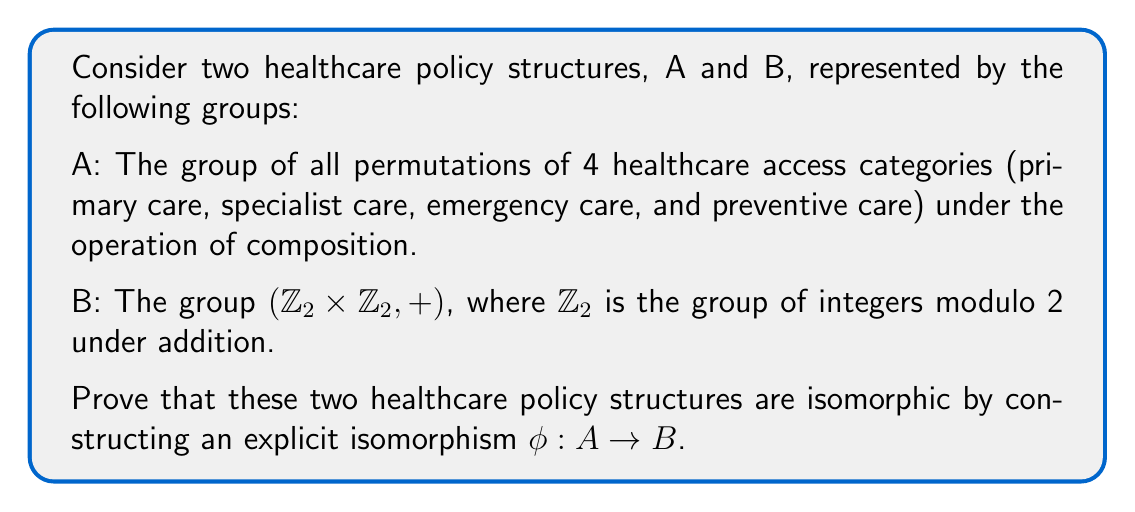Could you help me with this problem? To prove that the two healthcare policy structures A and B are isomorphic, we need to construct a bijective homomorphism $\phi: A \rightarrow B$. Let's approach this step-by-step:

1) First, let's analyze group A:
   - A is the symmetric group $S_4$, which has 24 elements.
   - However, we're only interested in the subgroup that consists of permutations that swap pairs of elements, which has 4 elements.

2) Now, let's look at group B:
   - B is $\mathbb{Z}_2 \times \mathbb{Z}_2$, which also has 4 elements: $(0,0)$, $(0,1)$, $(1,0)$, and $(1,1)$.

3) Let's define a mapping $\phi$ from A to B:
   - Let e be the identity permutation in A.
   - Let a be the permutation that swaps primary and specialist care.
   - Let b be the permutation that swaps emergency and preventive care.
   - Let c be the permutation that swaps both pairs simultaneously.

4) We can define $\phi$ as follows:
   $\phi(e) = (0,0)$
   $\phi(a) = (1,0)$
   $\phi(b) = (0,1)$
   $\phi(c) = (1,1)$

5) To prove this is an isomorphism, we need to show:
   a) $\phi$ is bijective (one-to-one and onto)
   b) $\phi$ preserves the group operation (homomorphism)

6) $\phi$ is bijective:
   - It's one-to-one because each element in A maps to a unique element in B.
   - It's onto because every element in B is mapped to by an element in A.

7) $\phi$ is a homomorphism:
   We need to show that for any two elements $x, y \in A$, $\phi(xy) = \phi(x) + \phi(y)$
   - For example, $\phi(ab) = \phi(c) = (1,1) = (1,0) + (0,1) = \phi(a) + \phi(b)$
   - This holds for all combinations of elements in A.

Therefore, $\phi$ is an isomorphism between A and B, proving that the two healthcare policy structures are isomorphic.
Answer: The isomorphism $\phi: A \rightarrow B$ is given by:
$$\phi(e) = (0,0)$$
$$\phi(a) = (1,0)$$
$$\phi(b) = (0,1)$$
$$\phi(c) = (1,1)$$
where e is the identity permutation, a swaps primary and specialist care, b swaps emergency and preventive care, and c swaps both pairs simultaneously. 